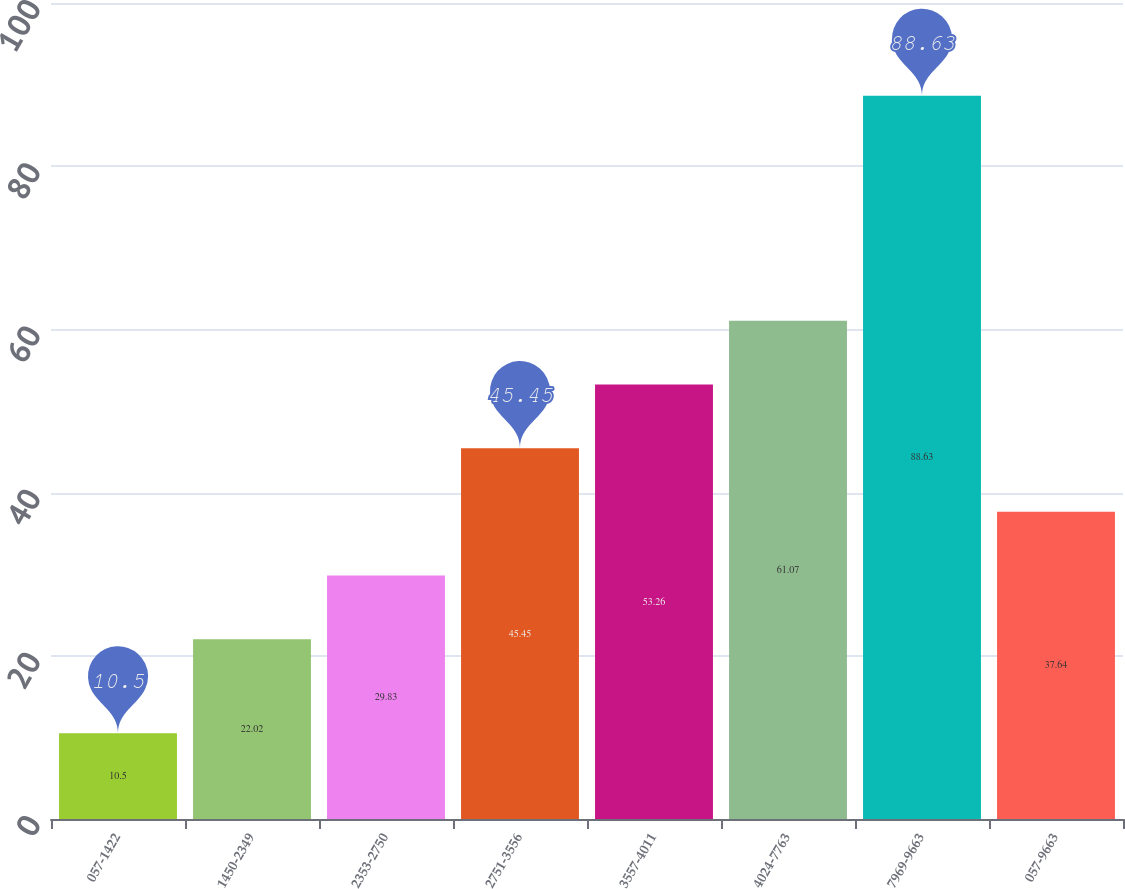Convert chart. <chart><loc_0><loc_0><loc_500><loc_500><bar_chart><fcel>057-1422<fcel>1450-2349<fcel>2353-2750<fcel>2751-3556<fcel>3557-4011<fcel>4024-7763<fcel>7969-9663<fcel>057-9663<nl><fcel>10.5<fcel>22.02<fcel>29.83<fcel>45.45<fcel>53.26<fcel>61.07<fcel>88.63<fcel>37.64<nl></chart> 